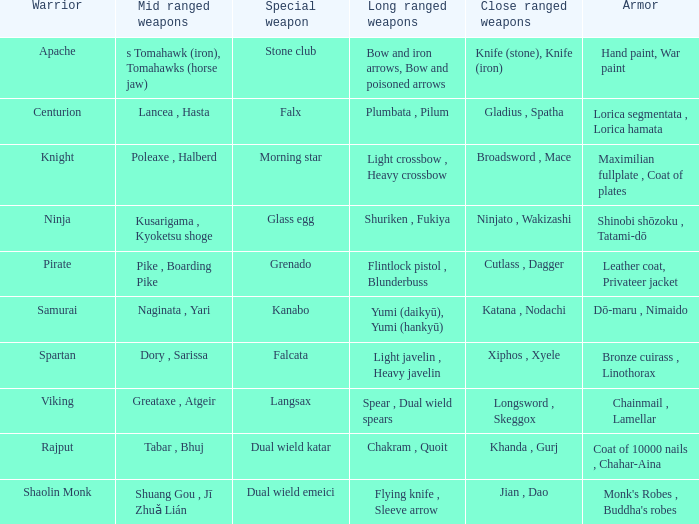If the Close ranged weapons are the knife (stone), knife (iron), what are the Long ranged weapons? Bow and iron arrows, Bow and poisoned arrows. 